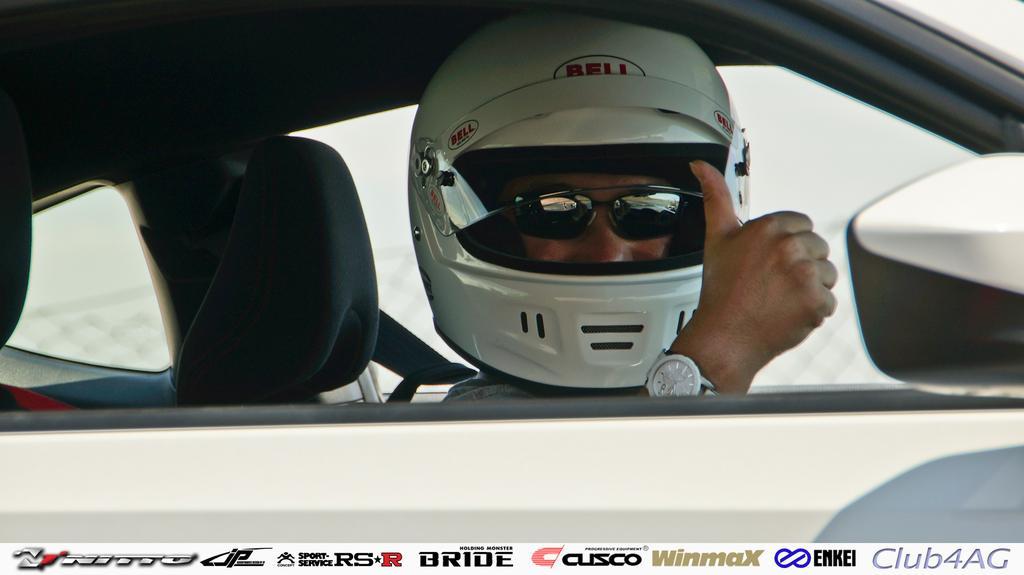Please provide a concise description of this image. In this picture there is a man in the center of the image inside a car, he is wearing a helmet and glasses. 